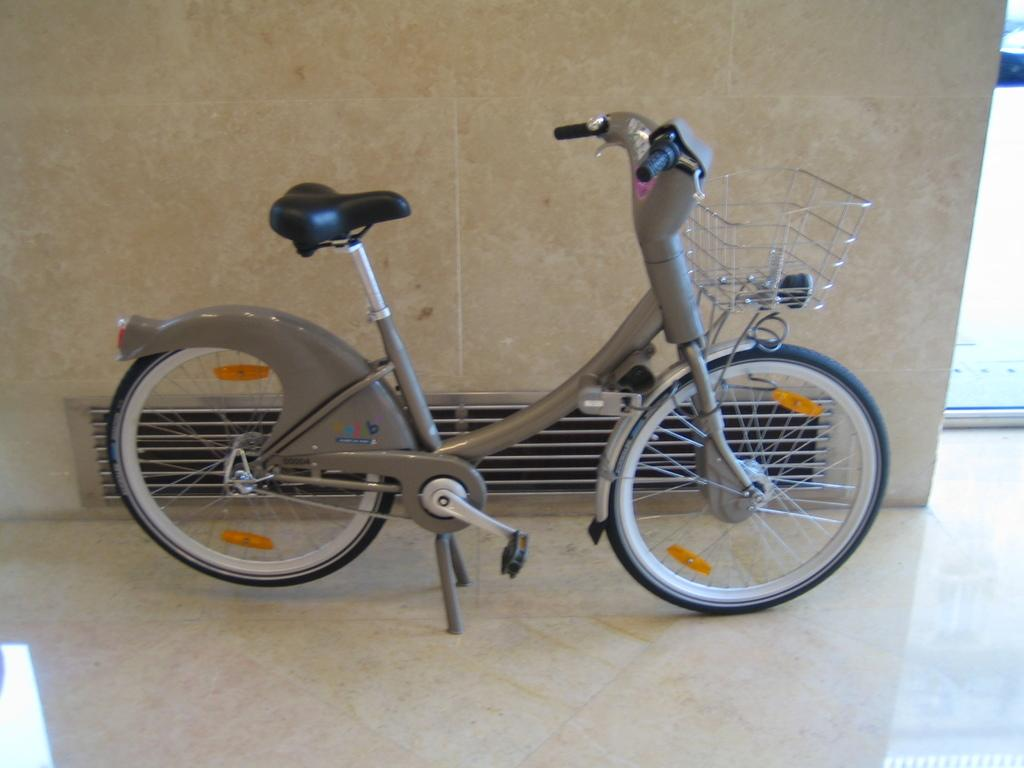What object is placed on the floor in the image? There is a bicycle on the floor in the image. What can be seen in the background of the image? There is a wall visible in the image. What type of gate can be seen in the image? There is no gate present in the image; it only features a bicycle on the floor and a wall in the background. 